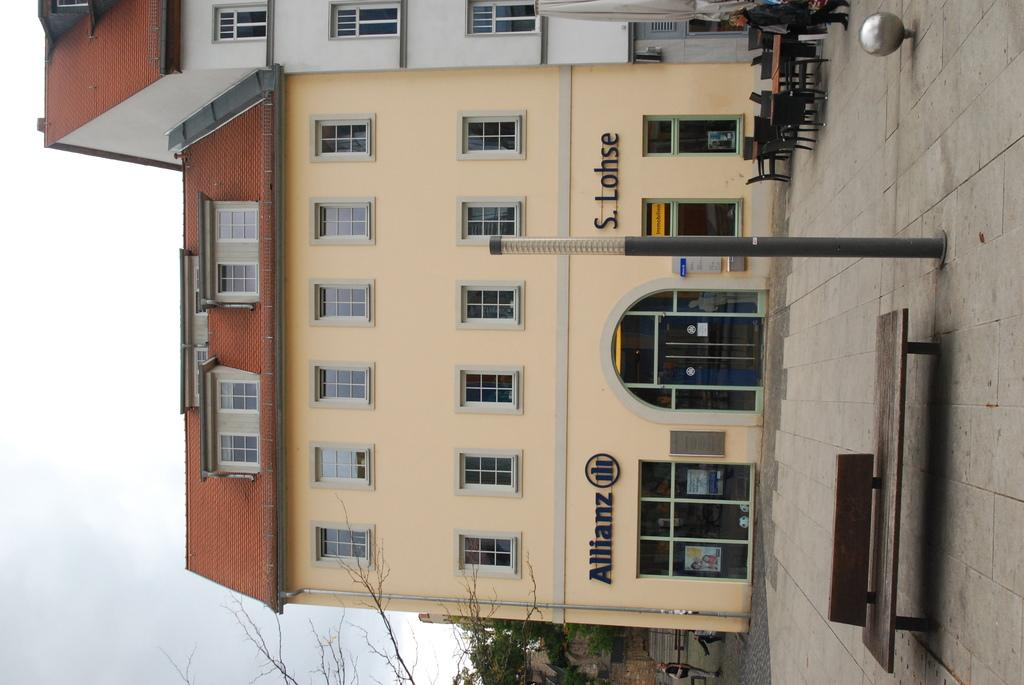<image>
Render a clear and concise summary of the photo. A bench is located outside of the Allianz building. 